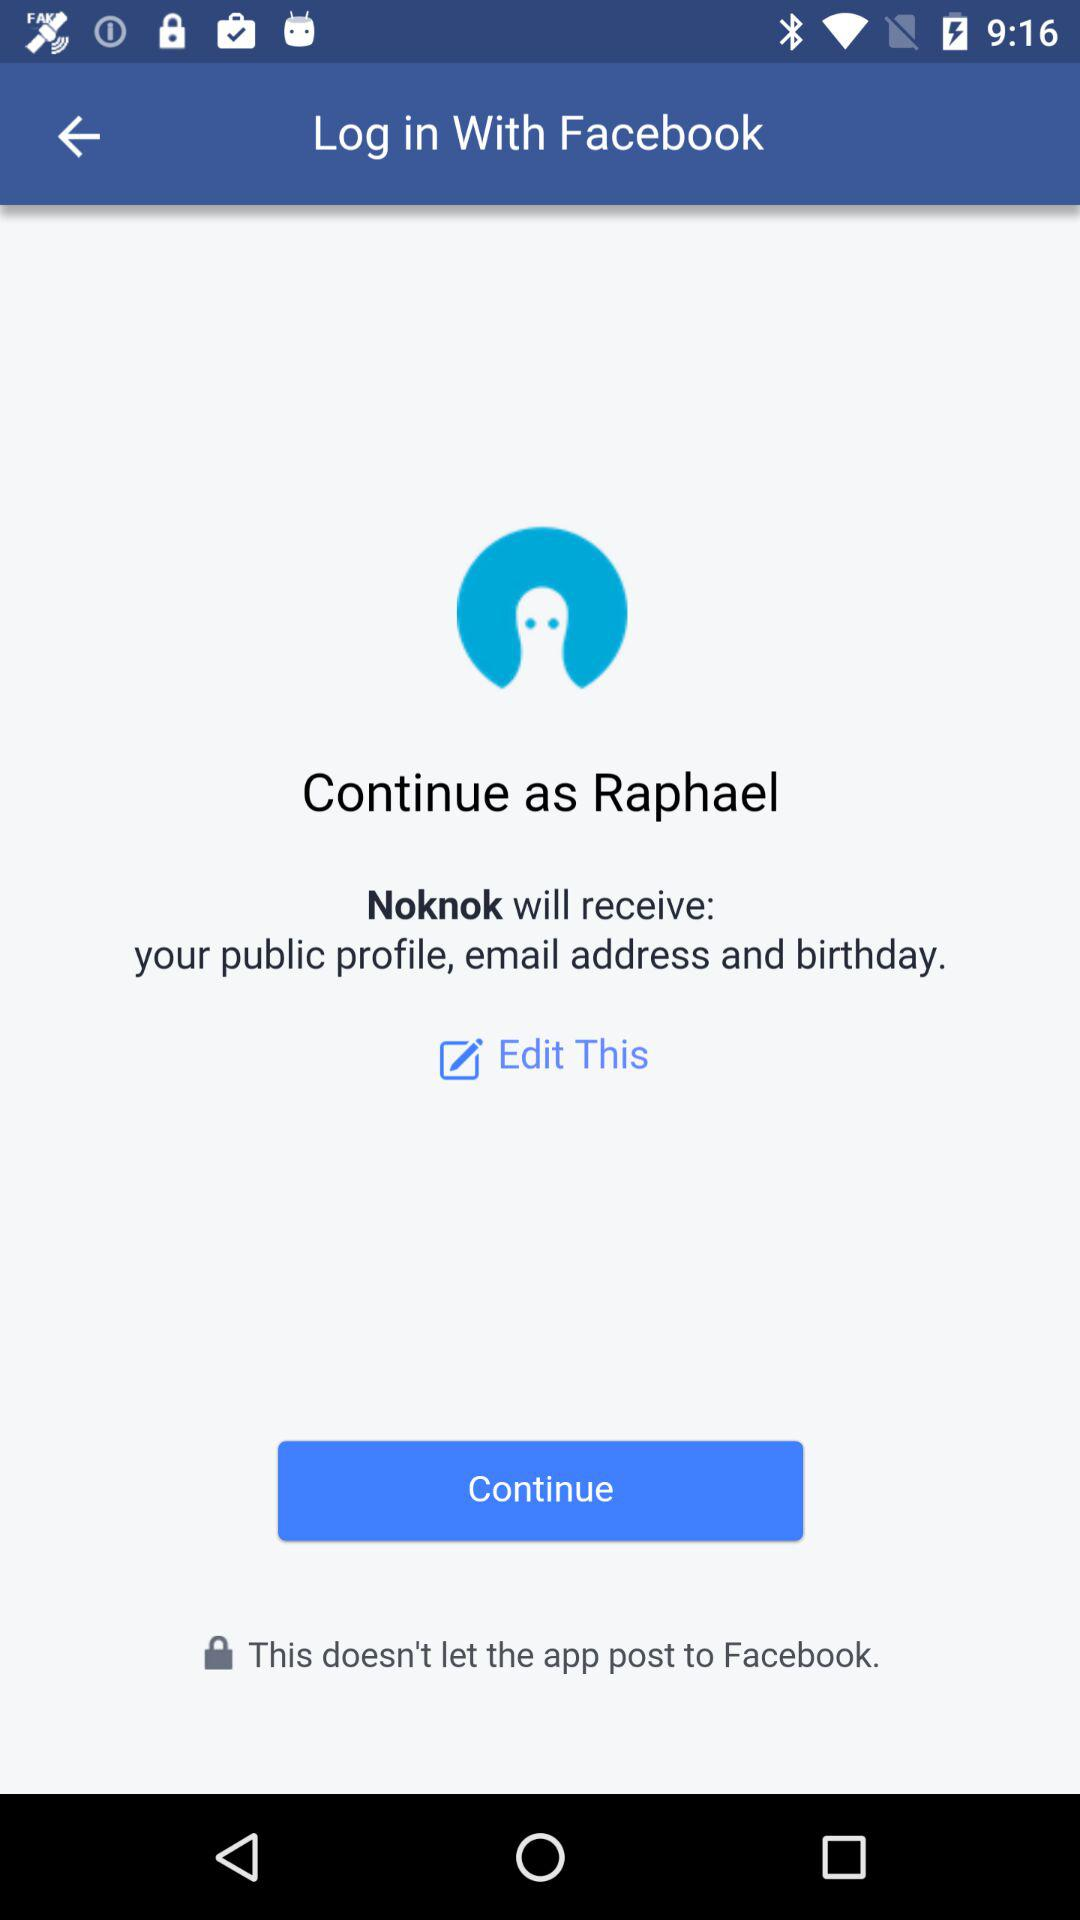Through what application can we log in? You can log in through "Facebook". 